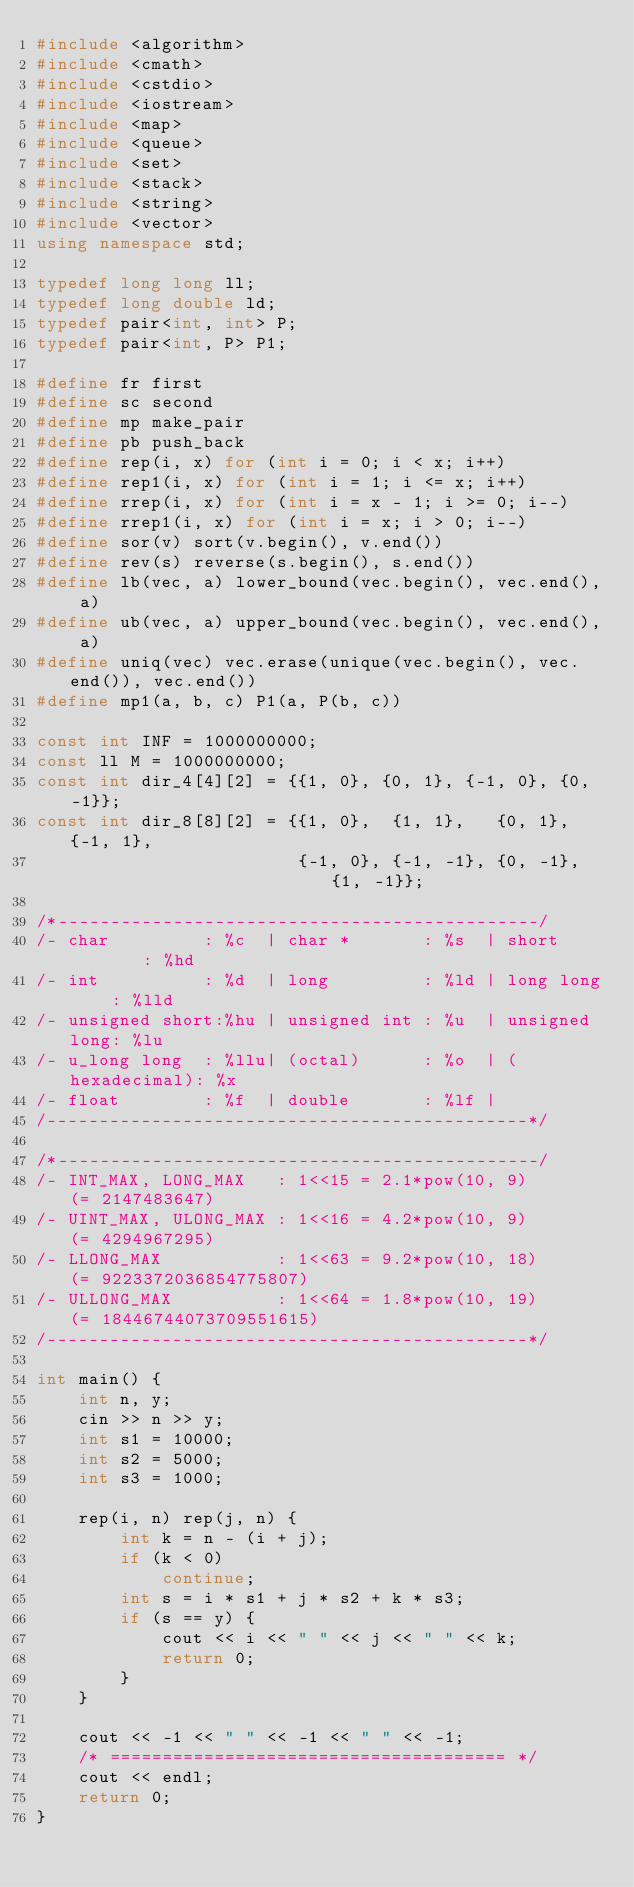<code> <loc_0><loc_0><loc_500><loc_500><_C++_>#include <algorithm>
#include <cmath>
#include <cstdio>
#include <iostream>
#include <map>
#include <queue>
#include <set>
#include <stack>
#include <string>
#include <vector>
using namespace std;

typedef long long ll;
typedef long double ld;
typedef pair<int, int> P;
typedef pair<int, P> P1;

#define fr first
#define sc second
#define mp make_pair
#define pb push_back
#define rep(i, x) for (int i = 0; i < x; i++)
#define rep1(i, x) for (int i = 1; i <= x; i++)
#define rrep(i, x) for (int i = x - 1; i >= 0; i--)
#define rrep1(i, x) for (int i = x; i > 0; i--)
#define sor(v) sort(v.begin(), v.end())
#define rev(s) reverse(s.begin(), s.end())
#define lb(vec, a) lower_bound(vec.begin(), vec.end(), a)
#define ub(vec, a) upper_bound(vec.begin(), vec.end(), a)
#define uniq(vec) vec.erase(unique(vec.begin(), vec.end()), vec.end())
#define mp1(a, b, c) P1(a, P(b, c))

const int INF = 1000000000;
const ll M = 1000000000;
const int dir_4[4][2] = {{1, 0}, {0, 1}, {-1, 0}, {0, -1}};
const int dir_8[8][2] = {{1, 0},  {1, 1},   {0, 1},  {-1, 1},
                         {-1, 0}, {-1, -1}, {0, -1}, {1, -1}};

/*----------------------------------------------/
/- char         : %c  | char *       : %s  | short        : %hd
/- int          : %d  | long         : %ld | long long    : %lld
/- unsigned short:%hu | unsigned int : %u  | unsigned long: %lu
/- u_long long  : %llu| (octal)      : %o  | (hexadecimal): %x
/- float        : %f  | double       : %lf |
/----------------------------------------------*/

/*----------------------------------------------/
/- INT_MAX, LONG_MAX   : 1<<15 = 2.1*pow(10, 9)       (= 2147483647)
/- UINT_MAX, ULONG_MAX : 1<<16 = 4.2*pow(10, 9)       (= 4294967295)
/- LLONG_MAX           : 1<<63 = 9.2*pow(10, 18)      (= 9223372036854775807)
/- ULLONG_MAX          : 1<<64 = 1.8*pow(10, 19)      (= 18446744073709551615)
/----------------------------------------------*/

int main() {
    int n, y;
    cin >> n >> y;
    int s1 = 10000;
    int s2 = 5000;
    int s3 = 1000;

    rep(i, n) rep(j, n) {
        int k = n - (i + j);
        if (k < 0)
            continue;
        int s = i * s1 + j * s2 + k * s3;
        if (s == y) {
            cout << i << " " << j << " " << k;
            return 0;
        }
    }

    cout << -1 << " " << -1 << " " << -1;
    /* ====================================== */
    cout << endl;
    return 0;
}</code> 